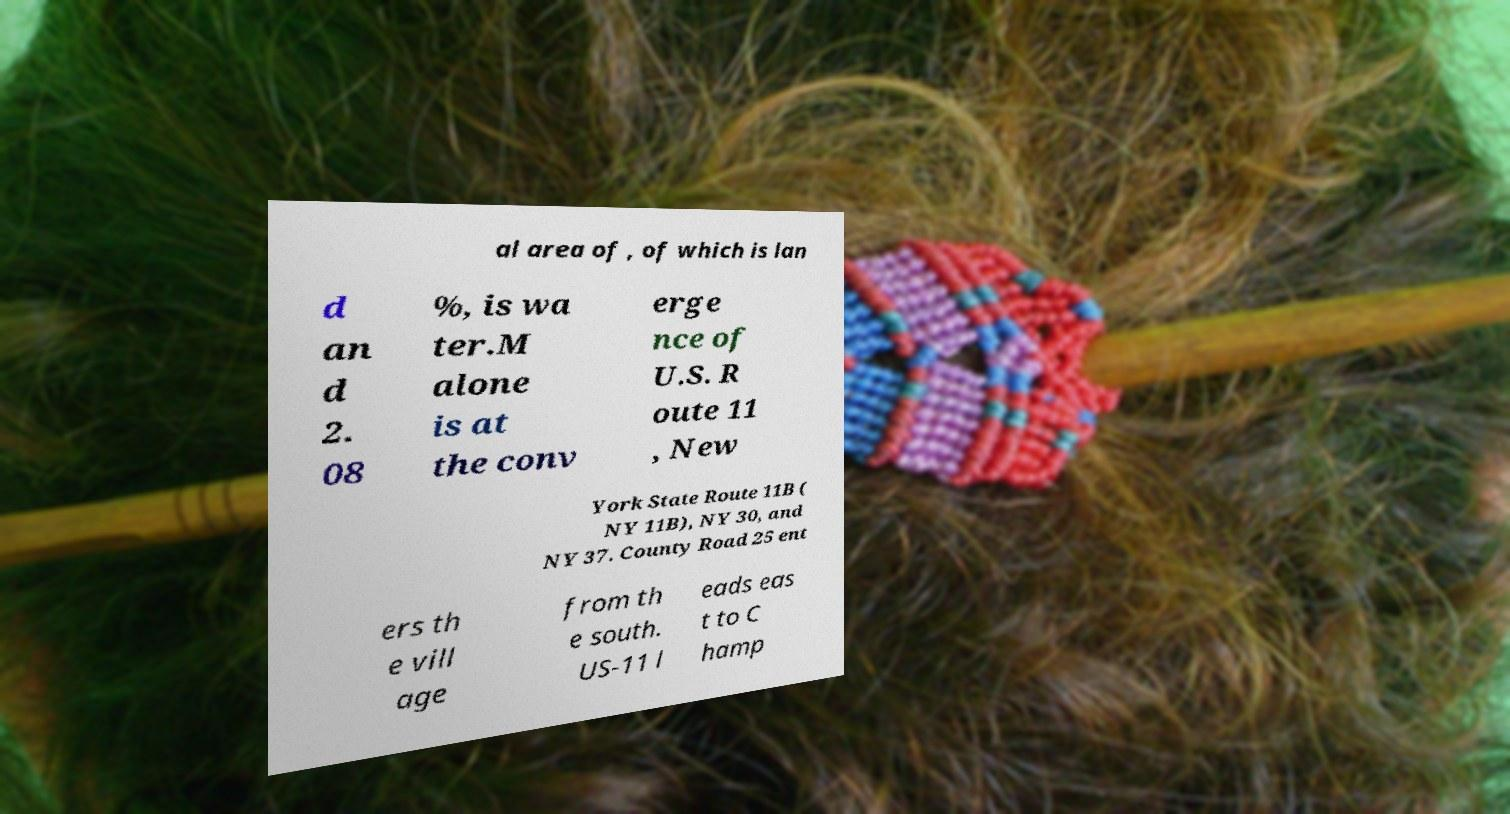I need the written content from this picture converted into text. Can you do that? al area of , of which is lan d an d 2. 08 %, is wa ter.M alone is at the conv erge nce of U.S. R oute 11 , New York State Route 11B ( NY 11B), NY 30, and NY 37. County Road 25 ent ers th e vill age from th e south. US-11 l eads eas t to C hamp 